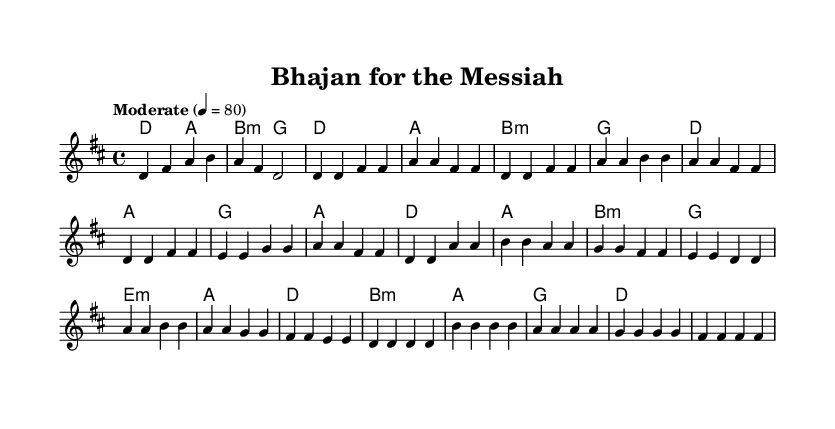What is the key signature of this music? The key signature is D major, which includes two sharps (F# and C#). We identify the key signature at the beginning of the staff, where the sharps are indicated.
Answer: D major What is the time signature of this music? The time signature is 4/4, indicated at the beginning of the sheet music next to the key signature. This means there are four beats in each measure, with the quarter note receiving one beat.
Answer: 4/4 What is the tempo marking for this piece? The tempo marking states "Moderate" with a metronome marking of 80. This indicates the desired speed of the piece, emphasizing a moderate pace for the performances.
Answer: Moderate 4 = 80 How many measures are in the chorus? The chorus consists of four measures as indicated by the musical notation in the chorus section. You can visually count the bar lines to determine the number of measures.
Answer: 4 What is the last note in the bridge section? The last note in the bridge section is D, indicated at the end of the bridge’s melody line. This can be found by locating the final note in the specified section of the sheet music.
Answer: D What are the primary chords used in the verse? The primary chords used in the verse are D, A, B minor, and G. These chords are indicated in the harmonies section, and we observe that they repeat throughout the verse.
Answer: D, A, B minor, G What unique element of Indian classical music is present in this contemporary worship piece? The unique element of Indian classical music present is the melodic ornamentation or improvisation style, which typically features in the melody lines. This is reflected in the expressive playing style suggested by the melody parts.
Answer: Ornamentation 